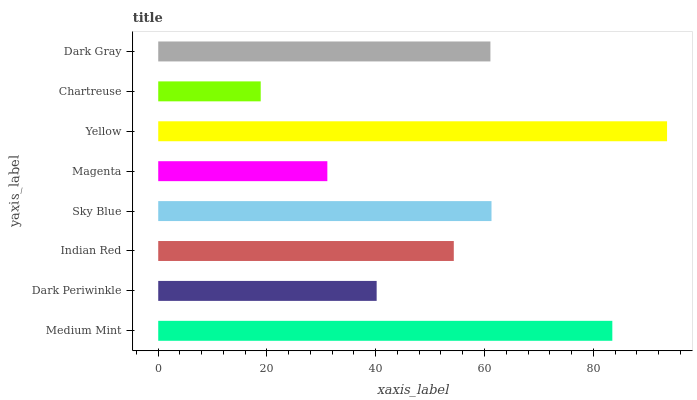Is Chartreuse the minimum?
Answer yes or no. Yes. Is Yellow the maximum?
Answer yes or no. Yes. Is Dark Periwinkle the minimum?
Answer yes or no. No. Is Dark Periwinkle the maximum?
Answer yes or no. No. Is Medium Mint greater than Dark Periwinkle?
Answer yes or no. Yes. Is Dark Periwinkle less than Medium Mint?
Answer yes or no. Yes. Is Dark Periwinkle greater than Medium Mint?
Answer yes or no. No. Is Medium Mint less than Dark Periwinkle?
Answer yes or no. No. Is Dark Gray the high median?
Answer yes or no. Yes. Is Indian Red the low median?
Answer yes or no. Yes. Is Sky Blue the high median?
Answer yes or no. No. Is Medium Mint the low median?
Answer yes or no. No. 